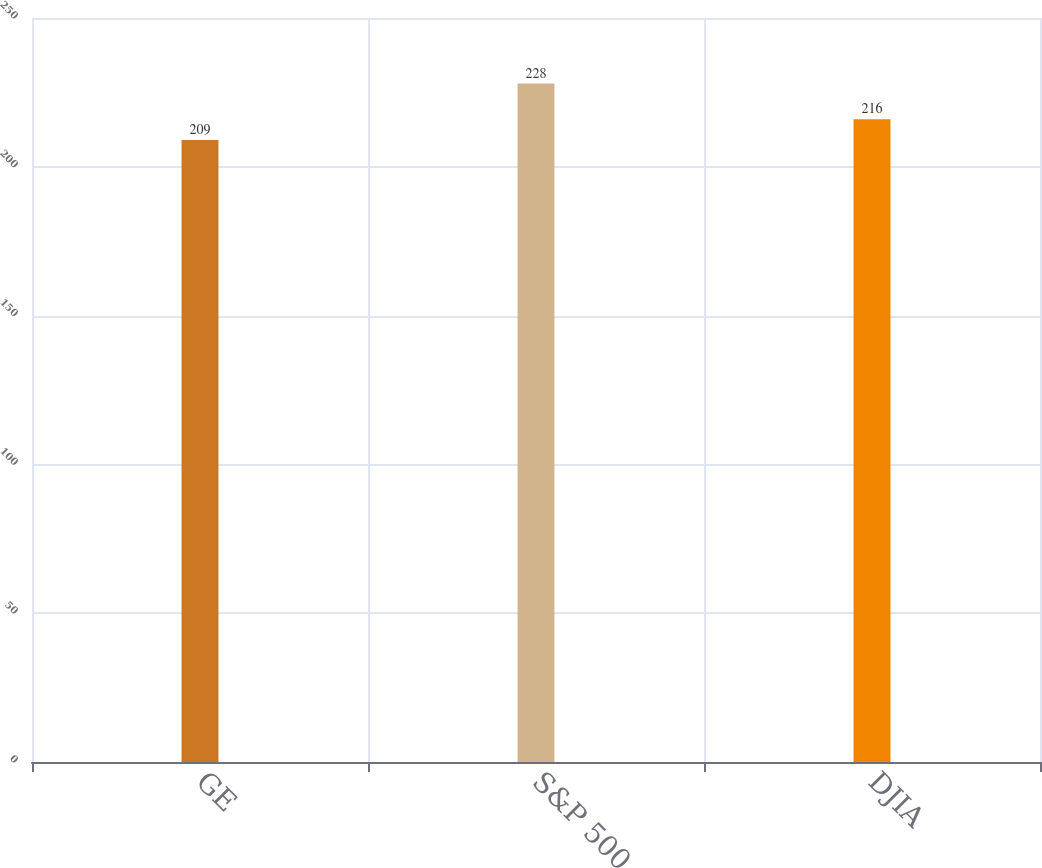Convert chart. <chart><loc_0><loc_0><loc_500><loc_500><bar_chart><fcel>GE<fcel>S&P 500<fcel>DJIA<nl><fcel>209<fcel>228<fcel>216<nl></chart> 